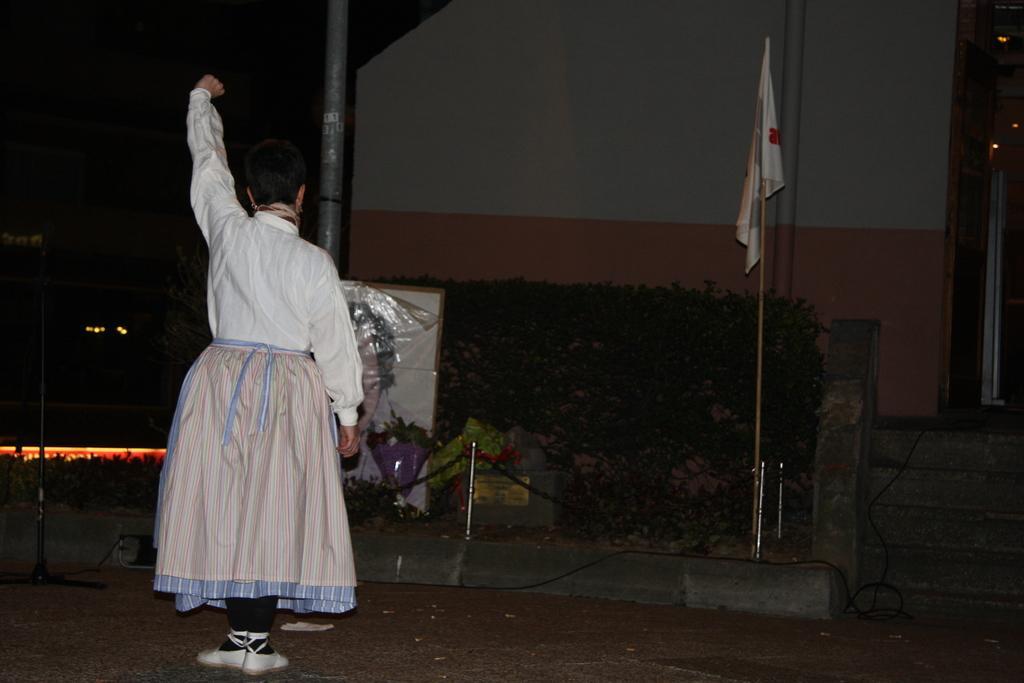How would you summarize this image in a sentence or two? In this image there is a woman standing on the ground. In front of her there is a pole. Near to the pole there is a board. There is a bouquet near the board. Around the pole there is a railing. Near to the railing there is a flag to a stick. Behind it there are hedges. In the background there is a wall of a house. To the right there are steps. To the left it is dark. 